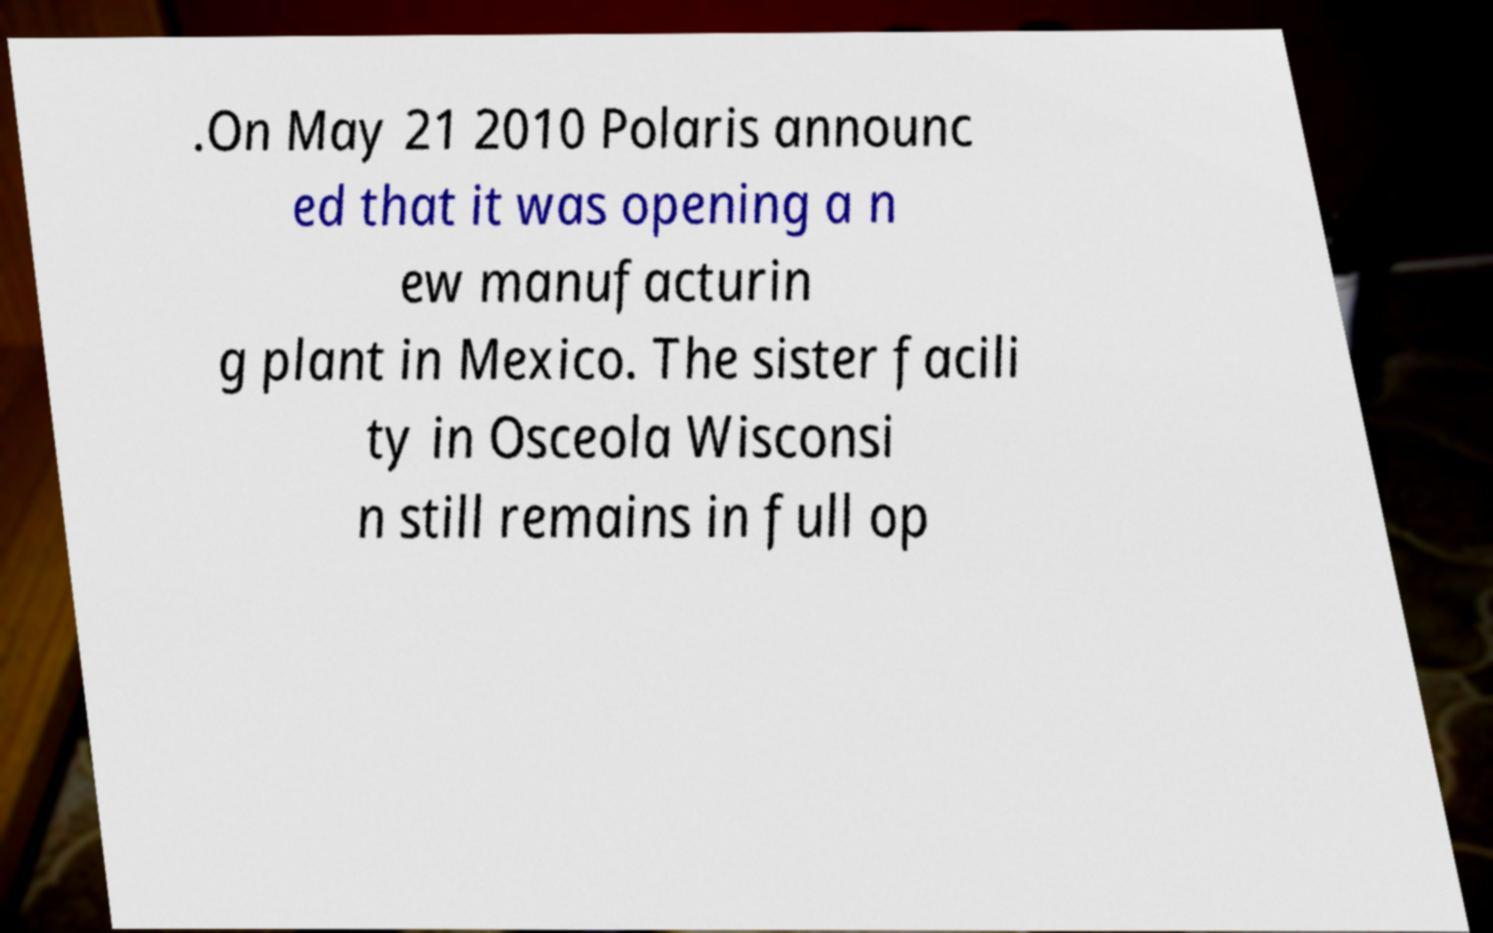Please read and relay the text visible in this image. What does it say? .On May 21 2010 Polaris announc ed that it was opening a n ew manufacturin g plant in Mexico. The sister facili ty in Osceola Wisconsi n still remains in full op 